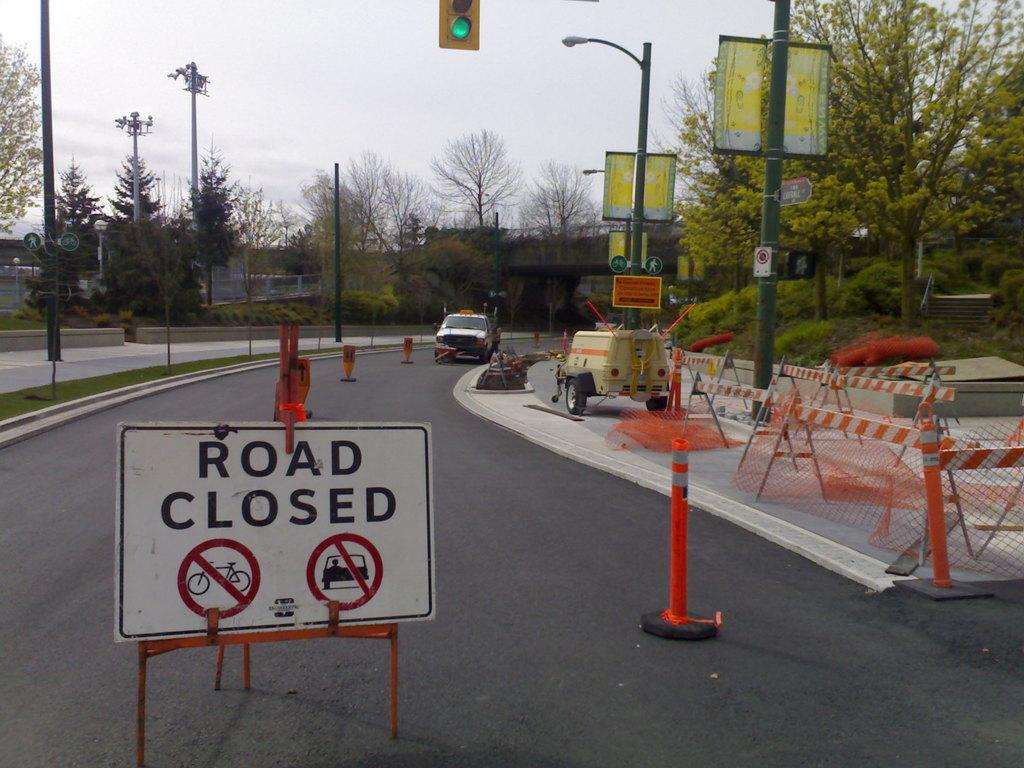<image>
Write a terse but informative summary of the picture. A construction zone that has a road closed sign in it. 